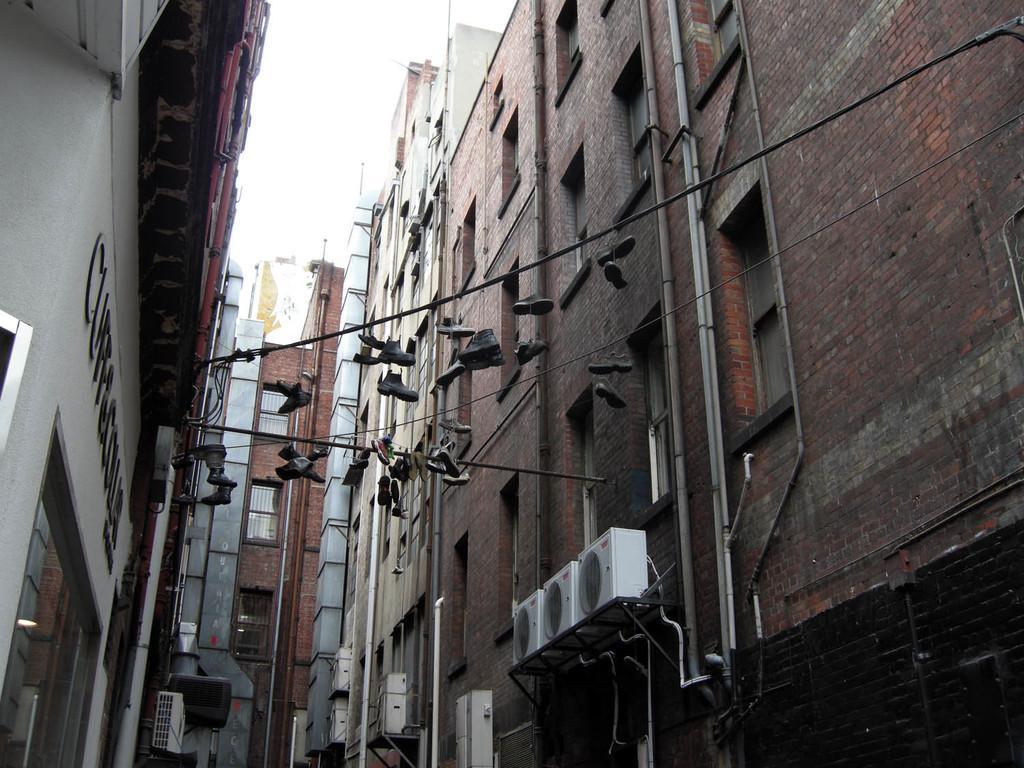In one or two sentences, can you explain what this image depicts? In this image I can see few buildings, number of windows, few pipes, few wires and here I can see number of shoes. I can also see few white colour things over here. 